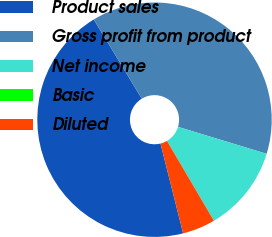Convert chart. <chart><loc_0><loc_0><loc_500><loc_500><pie_chart><fcel>Product sales<fcel>Gross profit from product<fcel>Net income<fcel>Basic<fcel>Diluted<nl><fcel>45.25%<fcel>38.37%<fcel>11.83%<fcel>0.01%<fcel>4.53%<nl></chart> 